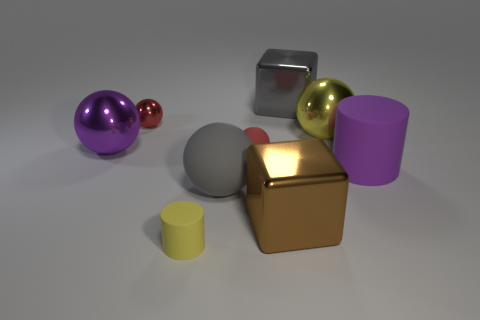Add 1 big yellow objects. How many objects exist? 10 Subtract all purple metallic balls. How many balls are left? 4 Subtract all blue blocks. Subtract all cyan balls. How many blocks are left? 2 Subtract all brown balls. How many purple cylinders are left? 1 Subtract all small brown shiny cylinders. Subtract all big brown cubes. How many objects are left? 8 Add 9 large purple spheres. How many large purple spheres are left? 10 Add 5 red rubber spheres. How many red rubber spheres exist? 6 Subtract all brown blocks. How many blocks are left? 1 Subtract 1 yellow spheres. How many objects are left? 8 Subtract all spheres. How many objects are left? 4 